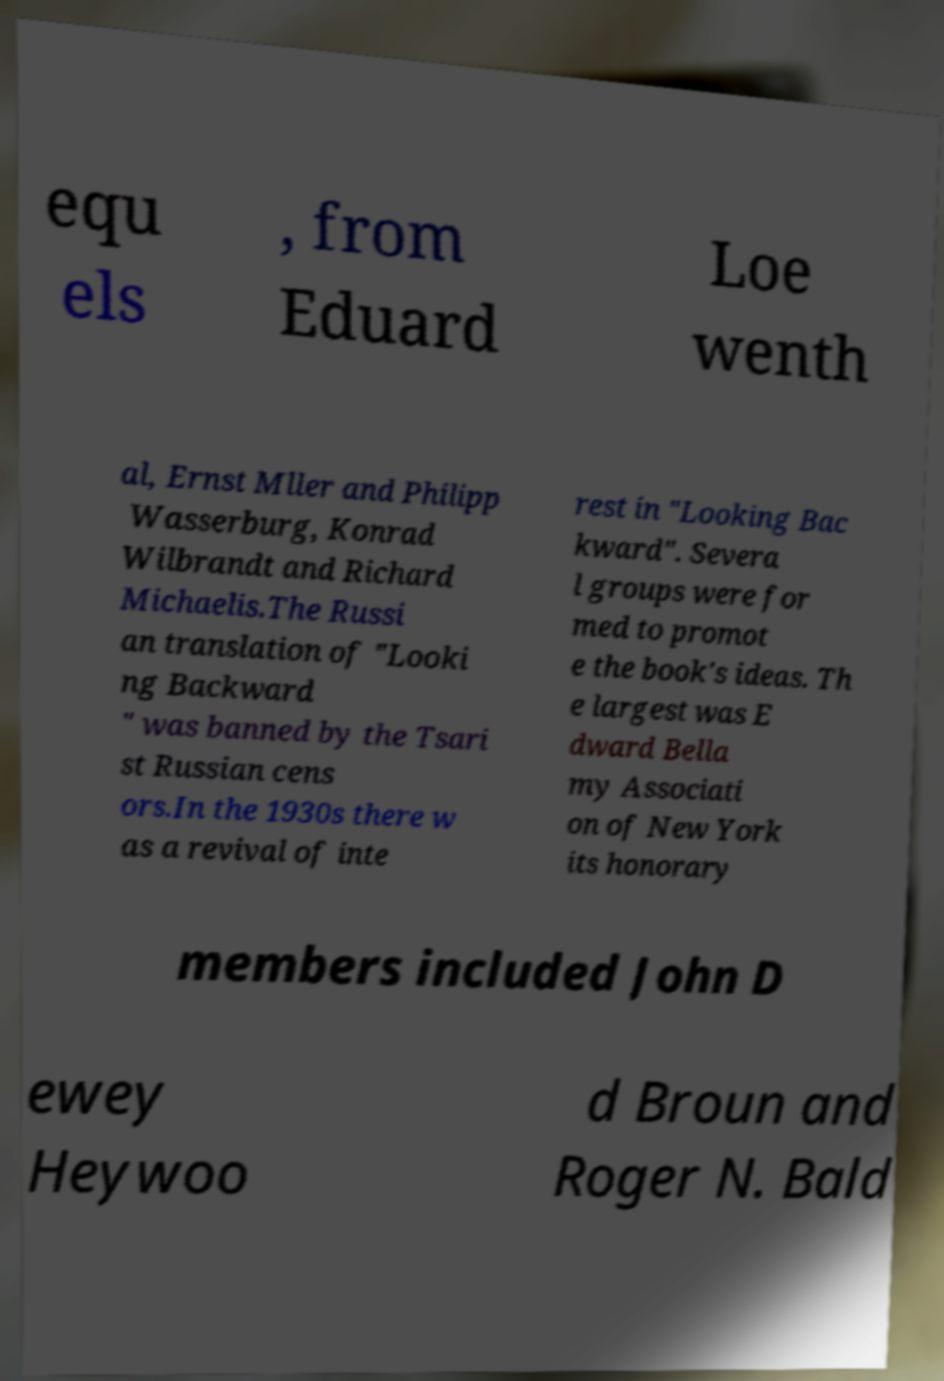Please identify and transcribe the text found in this image. equ els , from Eduard Loe wenth al, Ernst Mller and Philipp Wasserburg, Konrad Wilbrandt and Richard Michaelis.The Russi an translation of "Looki ng Backward " was banned by the Tsari st Russian cens ors.In the 1930s there w as a revival of inte rest in "Looking Bac kward". Severa l groups were for med to promot e the book's ideas. Th e largest was E dward Bella my Associati on of New York its honorary members included John D ewey Heywoo d Broun and Roger N. Bald 